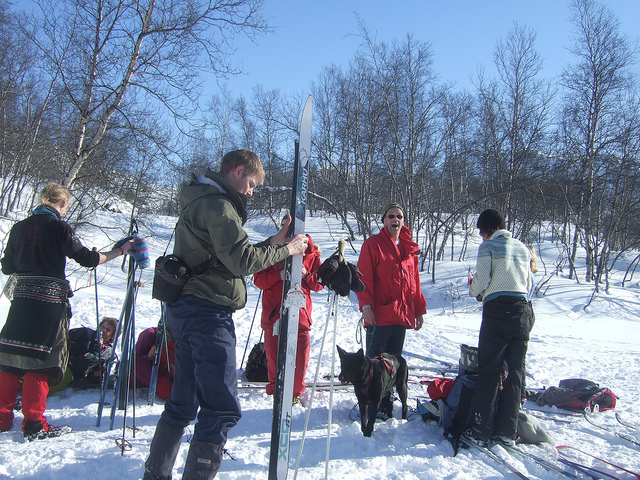Please identify all text content in this image. KARHU 